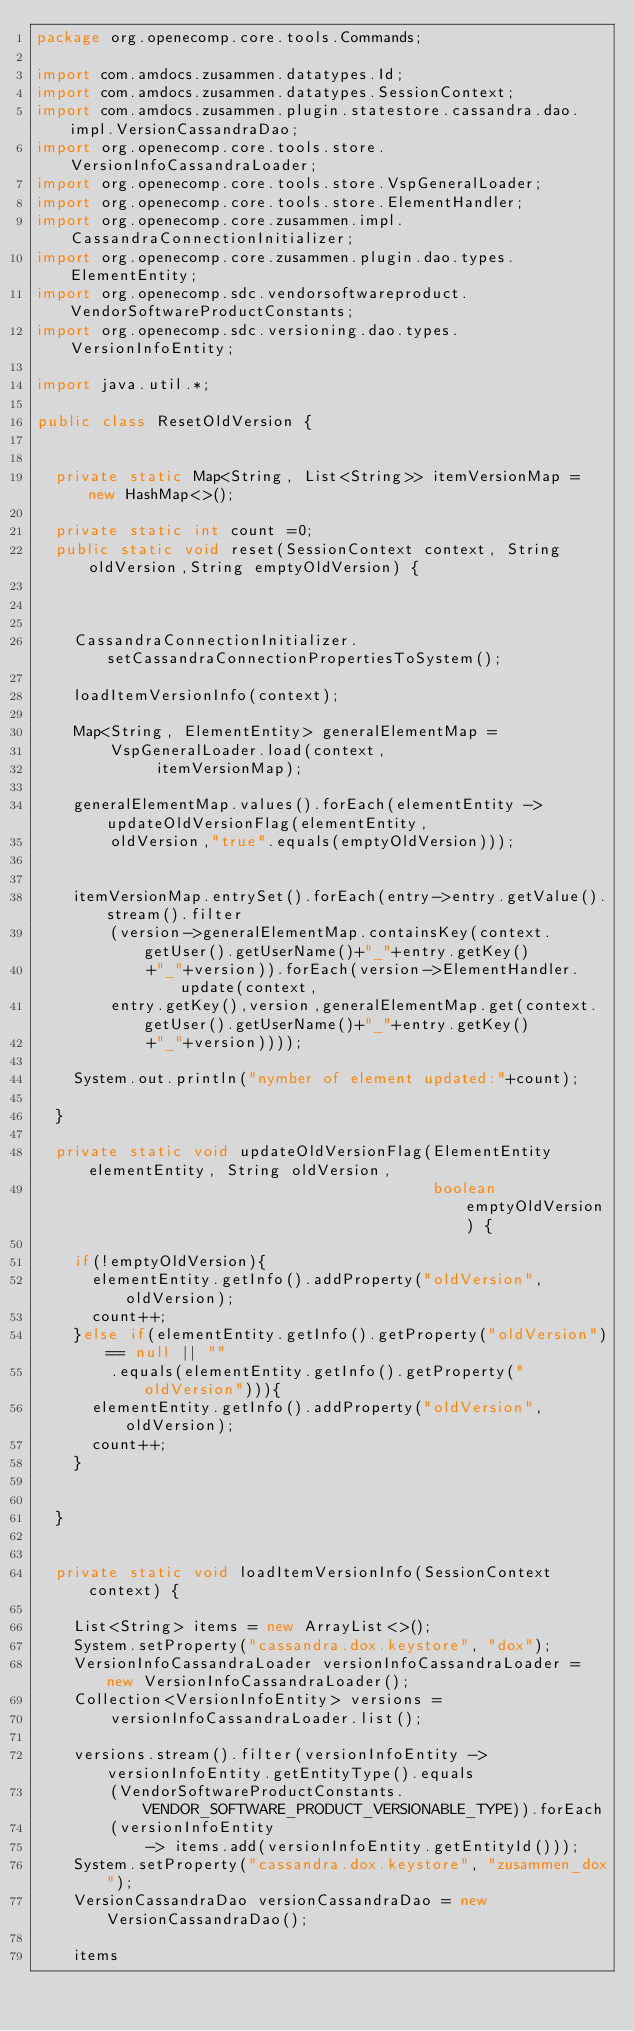<code> <loc_0><loc_0><loc_500><loc_500><_Java_>package org.openecomp.core.tools.Commands;

import com.amdocs.zusammen.datatypes.Id;
import com.amdocs.zusammen.datatypes.SessionContext;
import com.amdocs.zusammen.plugin.statestore.cassandra.dao.impl.VersionCassandraDao;
import org.openecomp.core.tools.store.VersionInfoCassandraLoader;
import org.openecomp.core.tools.store.VspGeneralLoader;
import org.openecomp.core.tools.store.ElementHandler;
import org.openecomp.core.zusammen.impl.CassandraConnectionInitializer;
import org.openecomp.core.zusammen.plugin.dao.types.ElementEntity;
import org.openecomp.sdc.vendorsoftwareproduct.VendorSoftwareProductConstants;
import org.openecomp.sdc.versioning.dao.types.VersionInfoEntity;

import java.util.*;

public class ResetOldVersion {


  private static Map<String, List<String>> itemVersionMap = new HashMap<>();

  private static int count =0;
  public static void reset(SessionContext context, String oldVersion,String emptyOldVersion) {



    CassandraConnectionInitializer.setCassandraConnectionPropertiesToSystem();

    loadItemVersionInfo(context);

    Map<String, ElementEntity> generalElementMap =
        VspGeneralLoader.load(context,
             itemVersionMap);

    generalElementMap.values().forEach(elementEntity -> updateOldVersionFlag(elementEntity,
        oldVersion,"true".equals(emptyOldVersion)));


    itemVersionMap.entrySet().forEach(entry->entry.getValue().stream().filter
        (version->generalElementMap.containsKey(context.getUser().getUserName()+"_"+entry.getKey()
            +"_"+version)).forEach(version->ElementHandler.update(context,
        entry.getKey(),version,generalElementMap.get(context.getUser().getUserName()+"_"+entry.getKey()
            +"_"+version))));

    System.out.println("nymber of element updated:"+count);

  }

  private static void updateOldVersionFlag(ElementEntity elementEntity, String oldVersion,
                                           boolean emptyOldVersion) {

    if(!emptyOldVersion){
      elementEntity.getInfo().addProperty("oldVersion",oldVersion);
      count++;
    }else if(elementEntity.getInfo().getProperty("oldVersion")== null || ""
        .equals(elementEntity.getInfo().getProperty("oldVersion"))){
      elementEntity.getInfo().addProperty("oldVersion",oldVersion);
      count++;
    }


  }


  private static void loadItemVersionInfo(SessionContext context) {

    List<String> items = new ArrayList<>();
    System.setProperty("cassandra.dox.keystore", "dox");
    VersionInfoCassandraLoader versionInfoCassandraLoader = new VersionInfoCassandraLoader();
    Collection<VersionInfoEntity> versions =
        versionInfoCassandraLoader.list();

    versions.stream().filter(versionInfoEntity -> versionInfoEntity.getEntityType().equals
        (VendorSoftwareProductConstants.VENDOR_SOFTWARE_PRODUCT_VERSIONABLE_TYPE)).forEach
        (versionInfoEntity
            -> items.add(versionInfoEntity.getEntityId()));
    System.setProperty("cassandra.dox.keystore", "zusammen_dox");
    VersionCassandraDao versionCassandraDao = new VersionCassandraDao();

    items</code> 